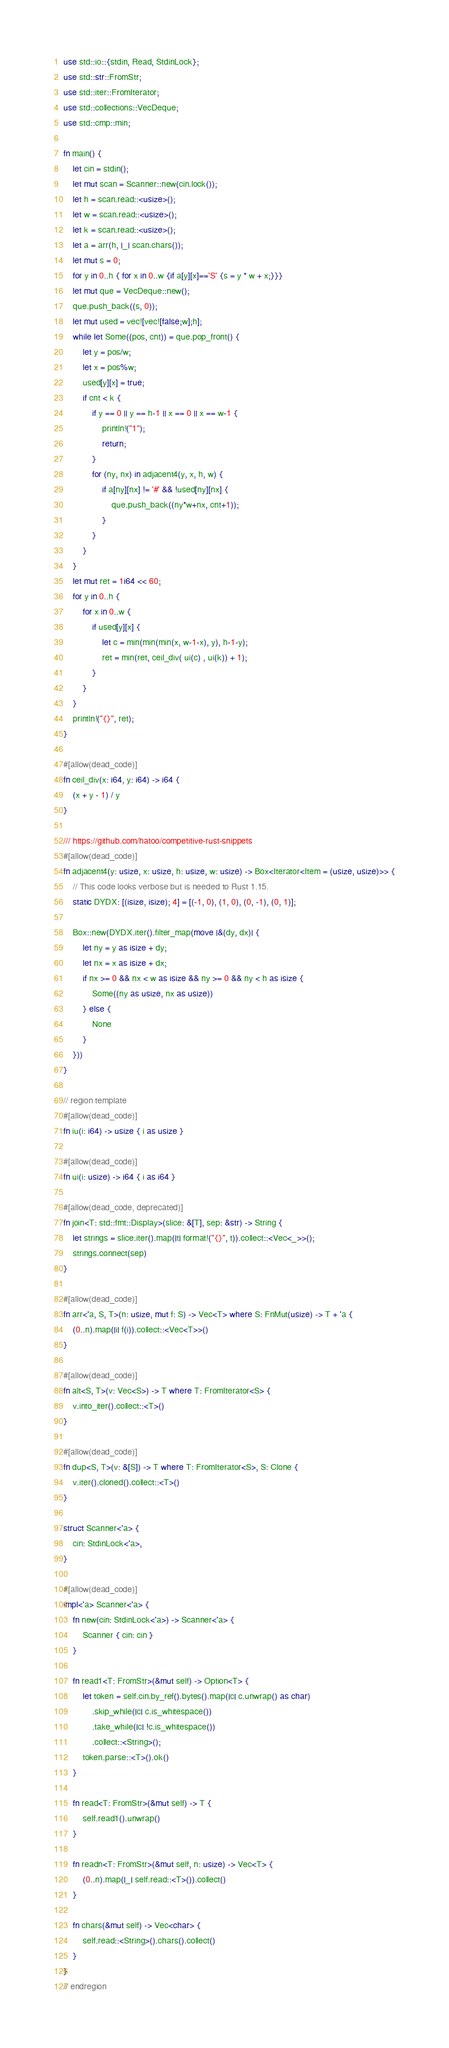<code> <loc_0><loc_0><loc_500><loc_500><_Rust_>use std::io::{stdin, Read, StdinLock};
use std::str::FromStr;
use std::iter::FromIterator;
use std::collections::VecDeque;
use std::cmp::min;

fn main() {
    let cin = stdin();
    let mut scan = Scanner::new(cin.lock());
    let h = scan.read::<usize>();
    let w = scan.read::<usize>();
    let k = scan.read::<usize>();
    let a = arr(h, |_| scan.chars());
    let mut s = 0;
    for y in 0..h { for x in 0..w {if a[y][x]=='S' {s = y * w + x;}}}
    let mut que = VecDeque::new();
    que.push_back((s, 0));
    let mut used = vec![vec![false;w];h];
    while let Some((pos, cnt)) = que.pop_front() {
        let y = pos/w;
        let x = pos%w;
        used[y][x] = true;
        if cnt < k {
            if y == 0 || y == h-1 || x == 0 || x == w-1 {
                println!("1");
                return;
            }
            for (ny, nx) in adjacent4(y, x, h, w) {
                if a[ny][nx] != '#' && !used[ny][nx] {
                    que.push_back((ny*w+nx, cnt+1));
                }
            }
        }
    }
    let mut ret = 1i64 << 60;
    for y in 0..h {
        for x in 0..w {
            if used[y][x] {
                let c = min(min(min(x, w-1-x), y), h-1-y);
                ret = min(ret, ceil_div( ui(c) , ui(k)) + 1);
            }
        }
    }
    println!("{}", ret);
}

#[allow(dead_code)]
fn ceil_div(x: i64, y: i64) -> i64 {
    (x + y - 1) / y
}

/// https://github.com/hatoo/competitive-rust-snippets
#[allow(dead_code)]
fn adjacent4(y: usize, x: usize, h: usize, w: usize) -> Box<Iterator<Item = (usize, usize)>> {
    // This code looks verbose but is needed to Rust 1.15.
    static DYDX: [(isize, isize); 4] = [(-1, 0), (1, 0), (0, -1), (0, 1)];

    Box::new(DYDX.iter().filter_map(move |&(dy, dx)| {
        let ny = y as isize + dy;
        let nx = x as isize + dx;
        if nx >= 0 && nx < w as isize && ny >= 0 && ny < h as isize {
            Some((ny as usize, nx as usize))
        } else {
            None
        }
    }))
}

// region template
#[allow(dead_code)]
fn iu(i: i64) -> usize { i as usize }

#[allow(dead_code)]
fn ui(i: usize) -> i64 { i as i64 }

#[allow(dead_code, deprecated)]
fn join<T: std::fmt::Display>(slice: &[T], sep: &str) -> String {
    let strings = slice.iter().map(|t| format!("{}", t)).collect::<Vec<_>>();
    strings.connect(sep)
}

#[allow(dead_code)]
fn arr<'a, S, T>(n: usize, mut f: S) -> Vec<T> where S: FnMut(usize) -> T + 'a {
    (0..n).map(|i| f(i)).collect::<Vec<T>>()
}

#[allow(dead_code)]
fn alt<S, T>(v: Vec<S>) -> T where T: FromIterator<S> {
    v.into_iter().collect::<T>()
}

#[allow(dead_code)]
fn dup<S, T>(v: &[S]) -> T where T: FromIterator<S>, S: Clone {
    v.iter().cloned().collect::<T>()
}

struct Scanner<'a> {
    cin: StdinLock<'a>,
}

#[allow(dead_code)]
impl<'a> Scanner<'a> {
    fn new(cin: StdinLock<'a>) -> Scanner<'a> {
        Scanner { cin: cin }
    }

    fn read1<T: FromStr>(&mut self) -> Option<T> {
        let token = self.cin.by_ref().bytes().map(|c| c.unwrap() as char)
            .skip_while(|c| c.is_whitespace())
            .take_while(|c| !c.is_whitespace())
            .collect::<String>();
        token.parse::<T>().ok()
    }

    fn read<T: FromStr>(&mut self) -> T {
        self.read1().unwrap()
    }

    fn readn<T: FromStr>(&mut self, n: usize) -> Vec<T> {
        (0..n).map(|_| self.read::<T>()).collect()
    }

    fn chars(&mut self) -> Vec<char> {
        self.read::<String>().chars().collect()
    }
}
// endregion</code> 